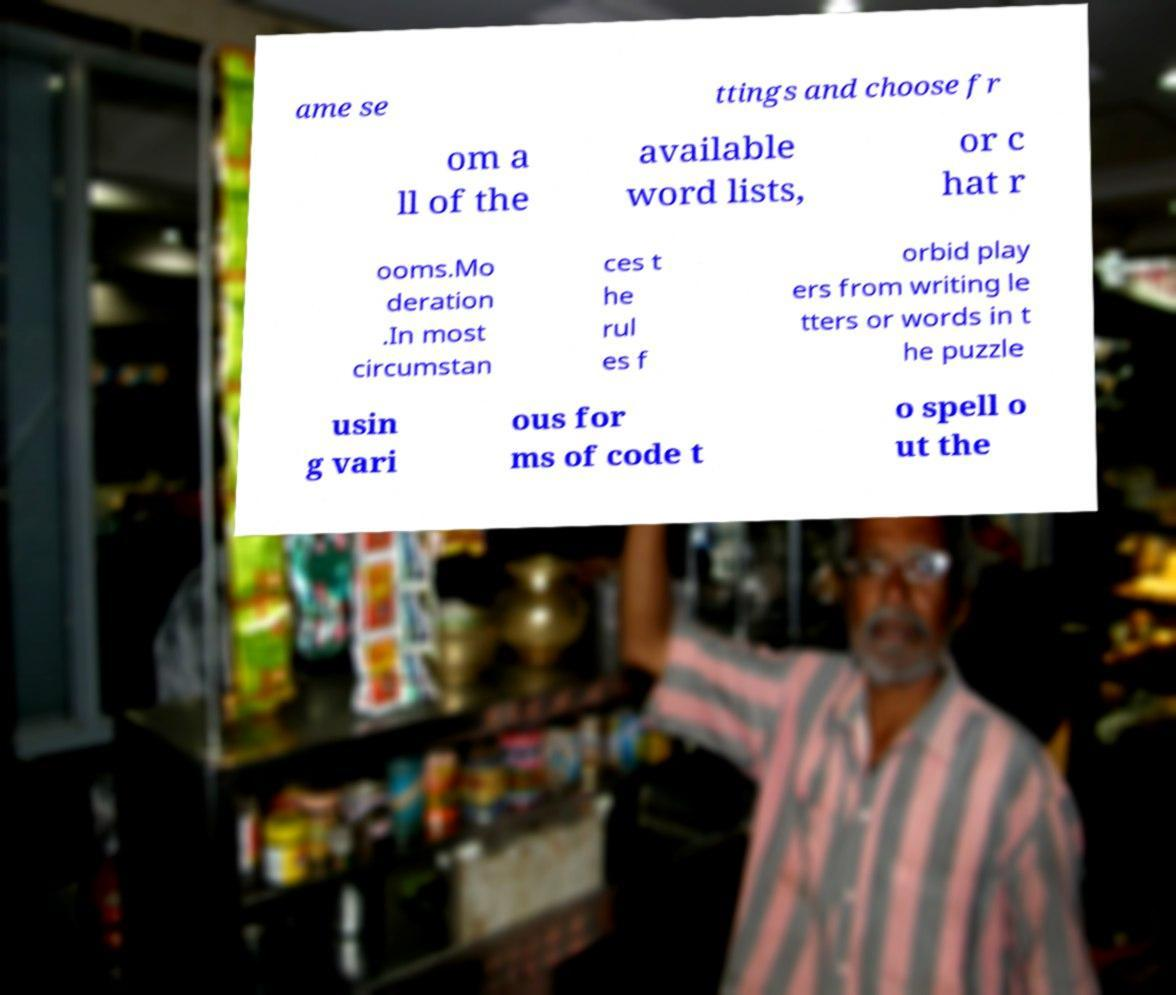Please read and relay the text visible in this image. What does it say? ame se ttings and choose fr om a ll of the available word lists, or c hat r ooms.Mo deration .In most circumstan ces t he rul es f orbid play ers from writing le tters or words in t he puzzle usin g vari ous for ms of code t o spell o ut the 